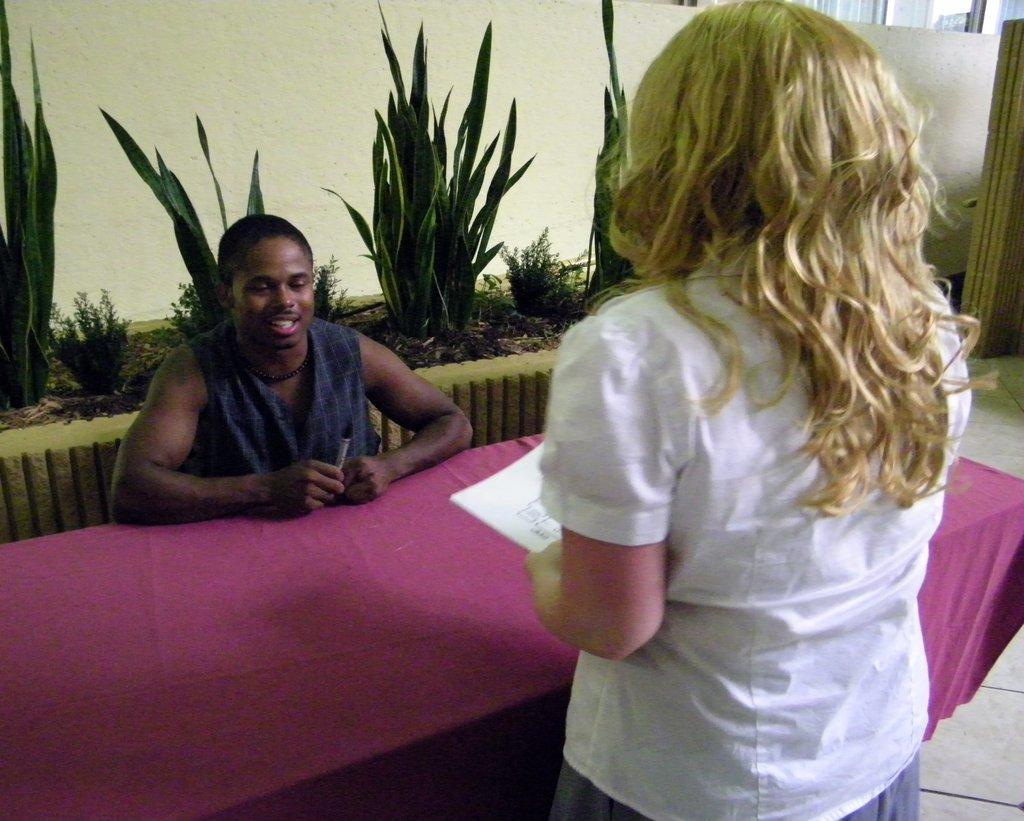Can you describe this image briefly? In this picture here we can see 2 people 1 is lady standing in front of a table present. And the other is man who is sitting in the opposite side of the table and he is holding a pen. He is saying something to the lady. In the background we can see plants present. It seems like a reception. 